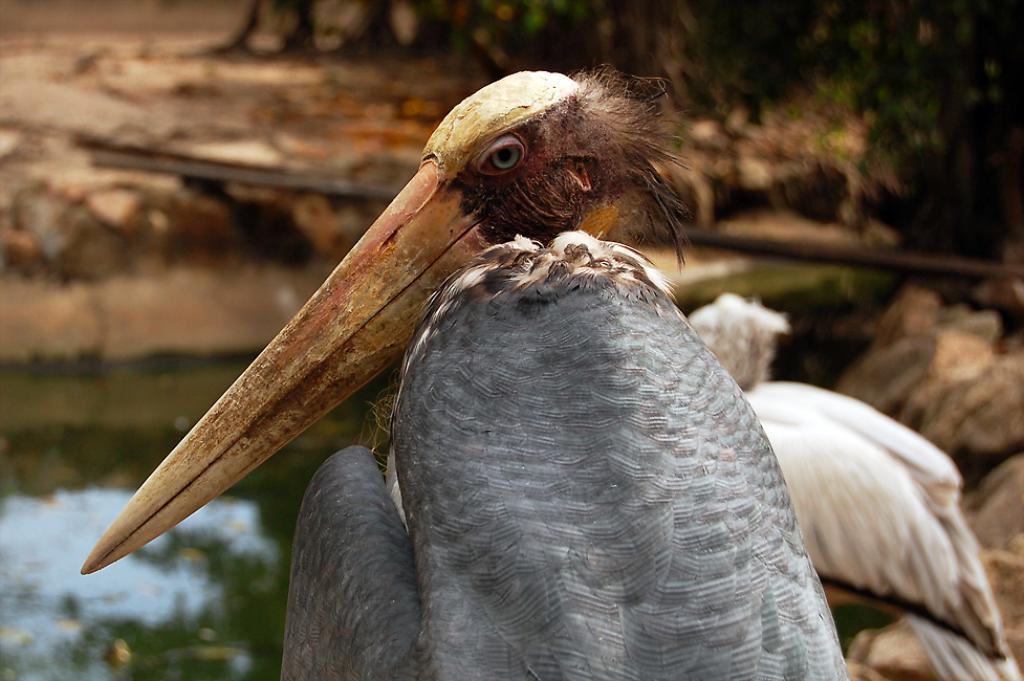Please provide a concise description of this image. In this image I can see a bird which is grey, brown, black, cream and orange in color. In the background I can see another bird which is white in color, the water, the ground and few trees. 